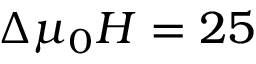<formula> <loc_0><loc_0><loc_500><loc_500>\Delta \mu _ { 0 } H = 2 5</formula> 